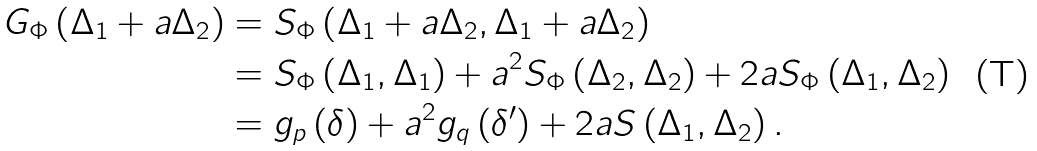<formula> <loc_0><loc_0><loc_500><loc_500>G _ { \Phi } \left ( \Delta _ { 1 } + a \Delta _ { 2 } \right ) & = S _ { \Phi } \left ( \Delta _ { 1 } + a \Delta _ { 2 } , \Delta _ { 1 } + a \Delta _ { 2 } \right ) \\ & = S _ { \Phi } \left ( \Delta _ { 1 } , \Delta _ { 1 } \right ) + a ^ { 2 } S _ { \Phi } \left ( \Delta _ { 2 } , \Delta _ { 2 } \right ) + 2 a S _ { \Phi } \left ( \Delta _ { 1 } , \Delta _ { 2 } \right ) \\ & = g _ { p } \left ( \delta \right ) + a ^ { 2 } g _ { q } \left ( \delta ^ { \prime } \right ) + 2 a S \left ( \Delta _ { 1 } , \Delta _ { 2 } \right ) .</formula> 